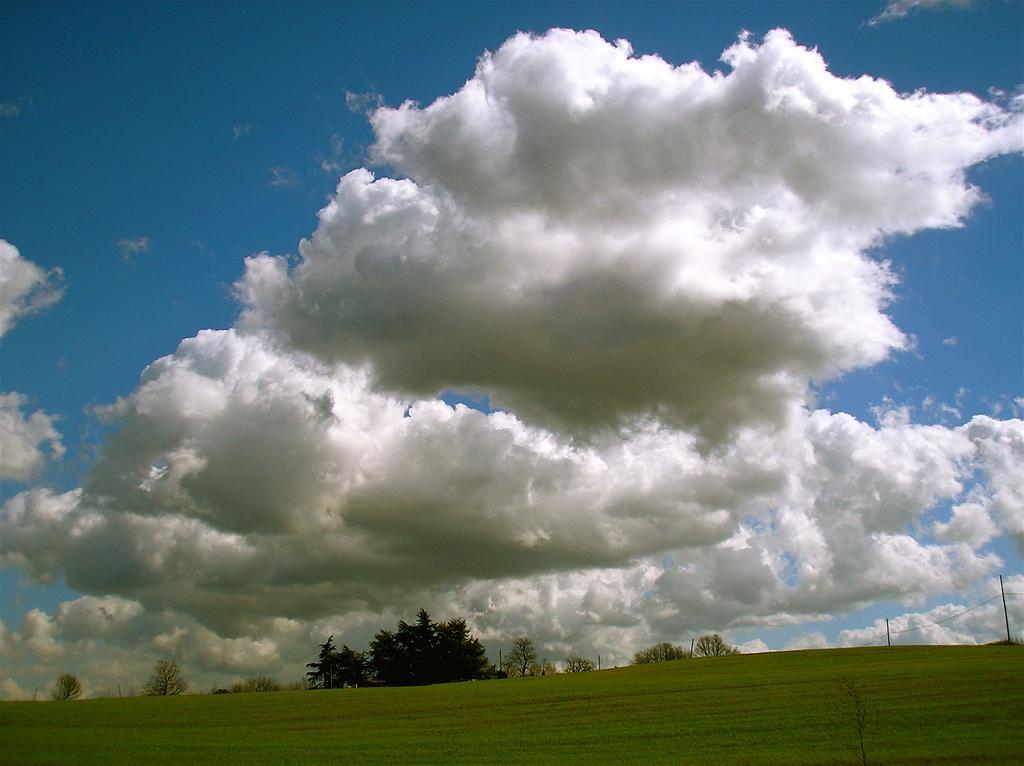How would you summarize this image in a sentence or two? In this image we can see sky with clouds on the top and on the bottom of the image there are trees, grass and pole with wires. 